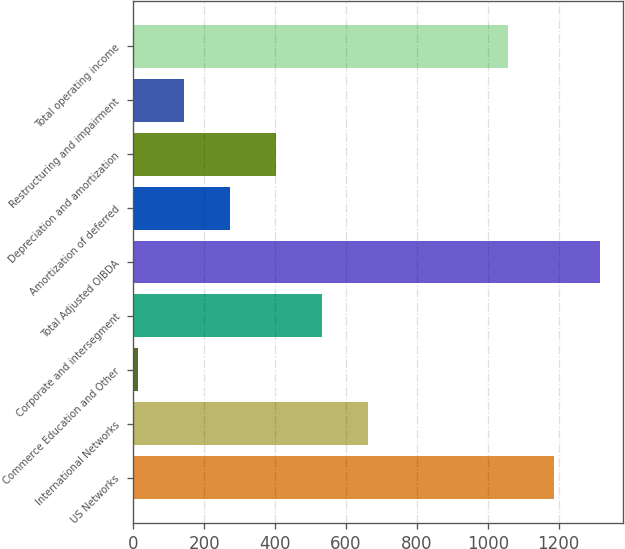<chart> <loc_0><loc_0><loc_500><loc_500><bar_chart><fcel>US Networks<fcel>International Networks<fcel>Commerce Education and Other<fcel>Corporate and intersegment<fcel>Total Adjusted OIBDA<fcel>Amortization of deferred<fcel>Depreciation and amortization<fcel>Restructuring and impairment<fcel>Total operating income<nl><fcel>1186.7<fcel>661.5<fcel>13<fcel>531.8<fcel>1316.4<fcel>272.4<fcel>402.1<fcel>142.7<fcel>1057<nl></chart> 